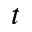Convert formula to latex. <formula><loc_0><loc_0><loc_500><loc_500>t</formula> 